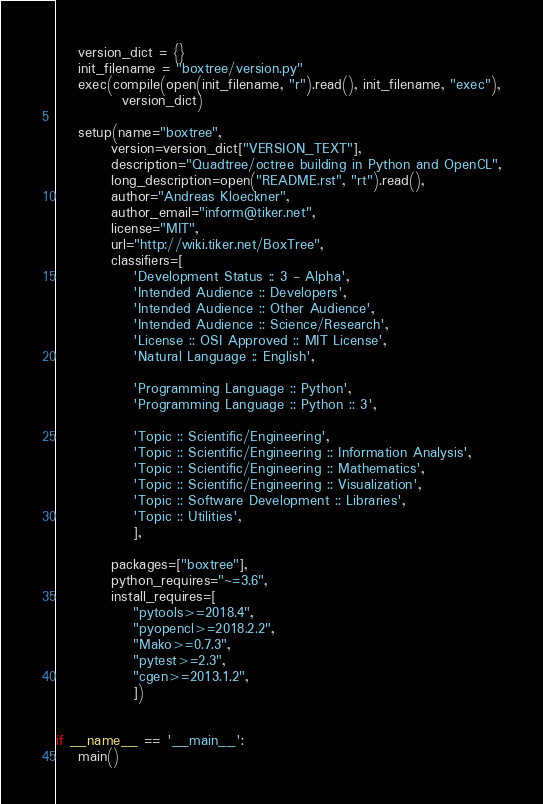Convert code to text. <code><loc_0><loc_0><loc_500><loc_500><_Python_>    version_dict = {}
    init_filename = "boxtree/version.py"
    exec(compile(open(init_filename, "r").read(), init_filename, "exec"),
            version_dict)

    setup(name="boxtree",
          version=version_dict["VERSION_TEXT"],
          description="Quadtree/octree building in Python and OpenCL",
          long_description=open("README.rst", "rt").read(),
          author="Andreas Kloeckner",
          author_email="inform@tiker.net",
          license="MIT",
          url="http://wiki.tiker.net/BoxTree",
          classifiers=[
              'Development Status :: 3 - Alpha',
              'Intended Audience :: Developers',
              'Intended Audience :: Other Audience',
              'Intended Audience :: Science/Research',
              'License :: OSI Approved :: MIT License',
              'Natural Language :: English',

              'Programming Language :: Python',
              'Programming Language :: Python :: 3',

              'Topic :: Scientific/Engineering',
              'Topic :: Scientific/Engineering :: Information Analysis',
              'Topic :: Scientific/Engineering :: Mathematics',
              'Topic :: Scientific/Engineering :: Visualization',
              'Topic :: Software Development :: Libraries',
              'Topic :: Utilities',
              ],

          packages=["boxtree"],
          python_requires="~=3.6",
          install_requires=[
              "pytools>=2018.4",
              "pyopencl>=2018.2.2",
              "Mako>=0.7.3",
              "pytest>=2.3",
              "cgen>=2013.1.2",
              ])


if __name__ == '__main__':
    main()
</code> 